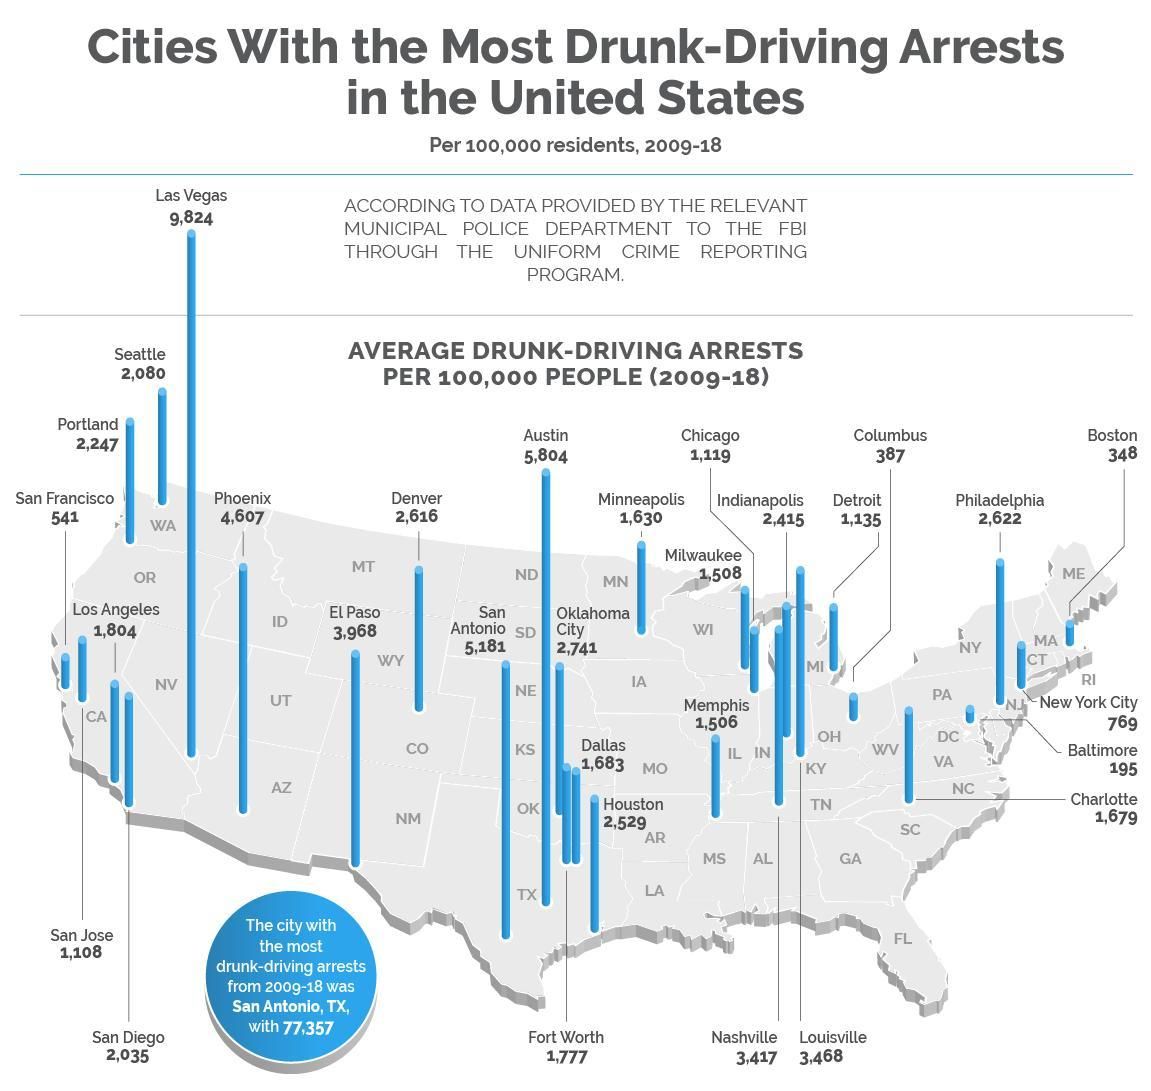What is the maximum drunk driving arrests recorded from 2009-18 in the United States?
Answer the question with a short phrase. 77,357 What is the average drunk-driving arrests per 100,000 people from 2009-18 in Portland? 2,247 Which city has the least drunk-driven arrests from 2009-18 in U.S.? Baltimore What is the average drunk-driving arrests per 100,000 people from 2009-18 in Columbus? 387 Which city has the most drunk-driven arrests from 2009-18 in U.S.? San Antonio, TX Which city has recorded the second lowest drunk-driven arrests from 2009-18 in U.S.? Boston 